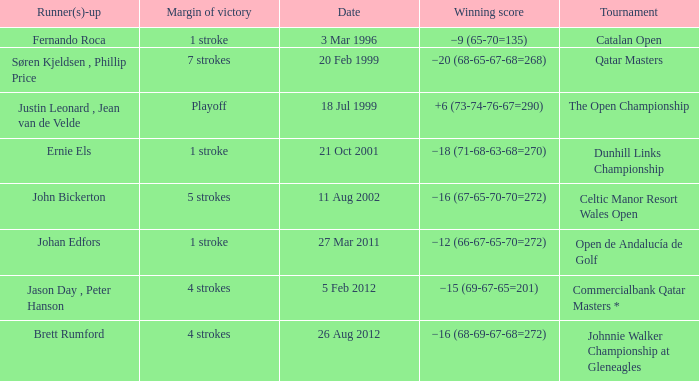What is the winning score for the runner-up Ernie Els? −18 (71-68-63-68=270). 